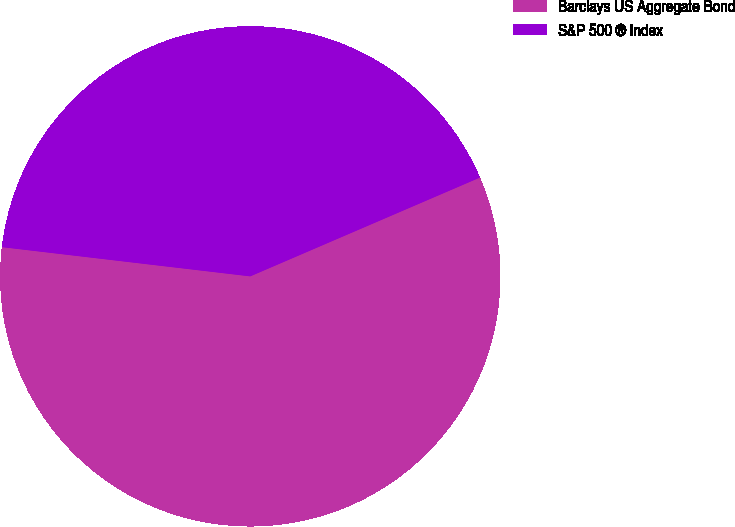Convert chart to OTSL. <chart><loc_0><loc_0><loc_500><loc_500><pie_chart><fcel>Barclays US Aggregate Bond<fcel>S&P 500 ® Index<nl><fcel>58.33%<fcel>41.67%<nl></chart> 